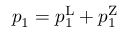Convert formula to latex. <formula><loc_0><loc_0><loc_500><loc_500>p _ { 1 } = p _ { 1 } ^ { L } + p _ { 1 } ^ { Z }</formula> 